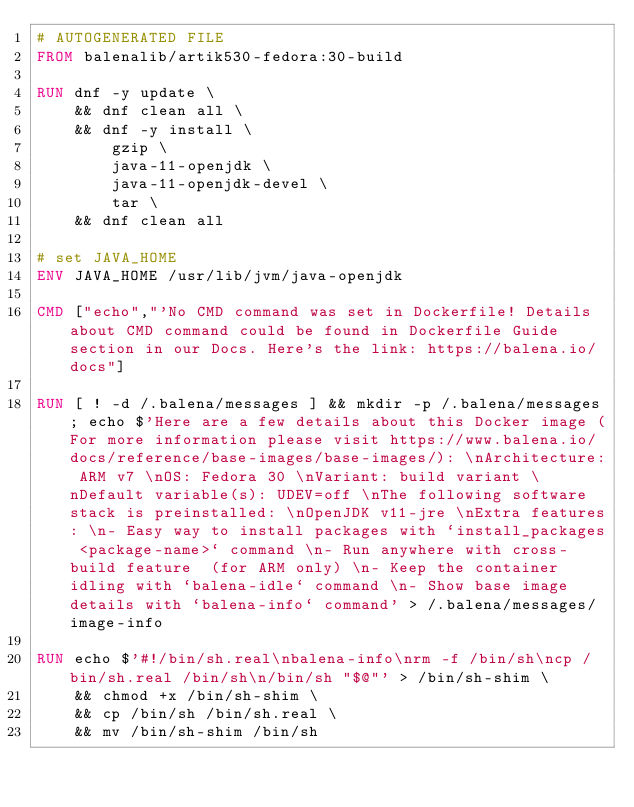<code> <loc_0><loc_0><loc_500><loc_500><_Dockerfile_># AUTOGENERATED FILE
FROM balenalib/artik530-fedora:30-build

RUN dnf -y update \
	&& dnf clean all \
	&& dnf -y install \
		gzip \
		java-11-openjdk \
		java-11-openjdk-devel \
		tar \
	&& dnf clean all

# set JAVA_HOME
ENV JAVA_HOME /usr/lib/jvm/java-openjdk

CMD ["echo","'No CMD command was set in Dockerfile! Details about CMD command could be found in Dockerfile Guide section in our Docs. Here's the link: https://balena.io/docs"]

RUN [ ! -d /.balena/messages ] && mkdir -p /.balena/messages; echo $'Here are a few details about this Docker image (For more information please visit https://www.balena.io/docs/reference/base-images/base-images/): \nArchitecture: ARM v7 \nOS: Fedora 30 \nVariant: build variant \nDefault variable(s): UDEV=off \nThe following software stack is preinstalled: \nOpenJDK v11-jre \nExtra features: \n- Easy way to install packages with `install_packages <package-name>` command \n- Run anywhere with cross-build feature  (for ARM only) \n- Keep the container idling with `balena-idle` command \n- Show base image details with `balena-info` command' > /.balena/messages/image-info

RUN echo $'#!/bin/sh.real\nbalena-info\nrm -f /bin/sh\ncp /bin/sh.real /bin/sh\n/bin/sh "$@"' > /bin/sh-shim \
	&& chmod +x /bin/sh-shim \
	&& cp /bin/sh /bin/sh.real \
	&& mv /bin/sh-shim /bin/sh</code> 